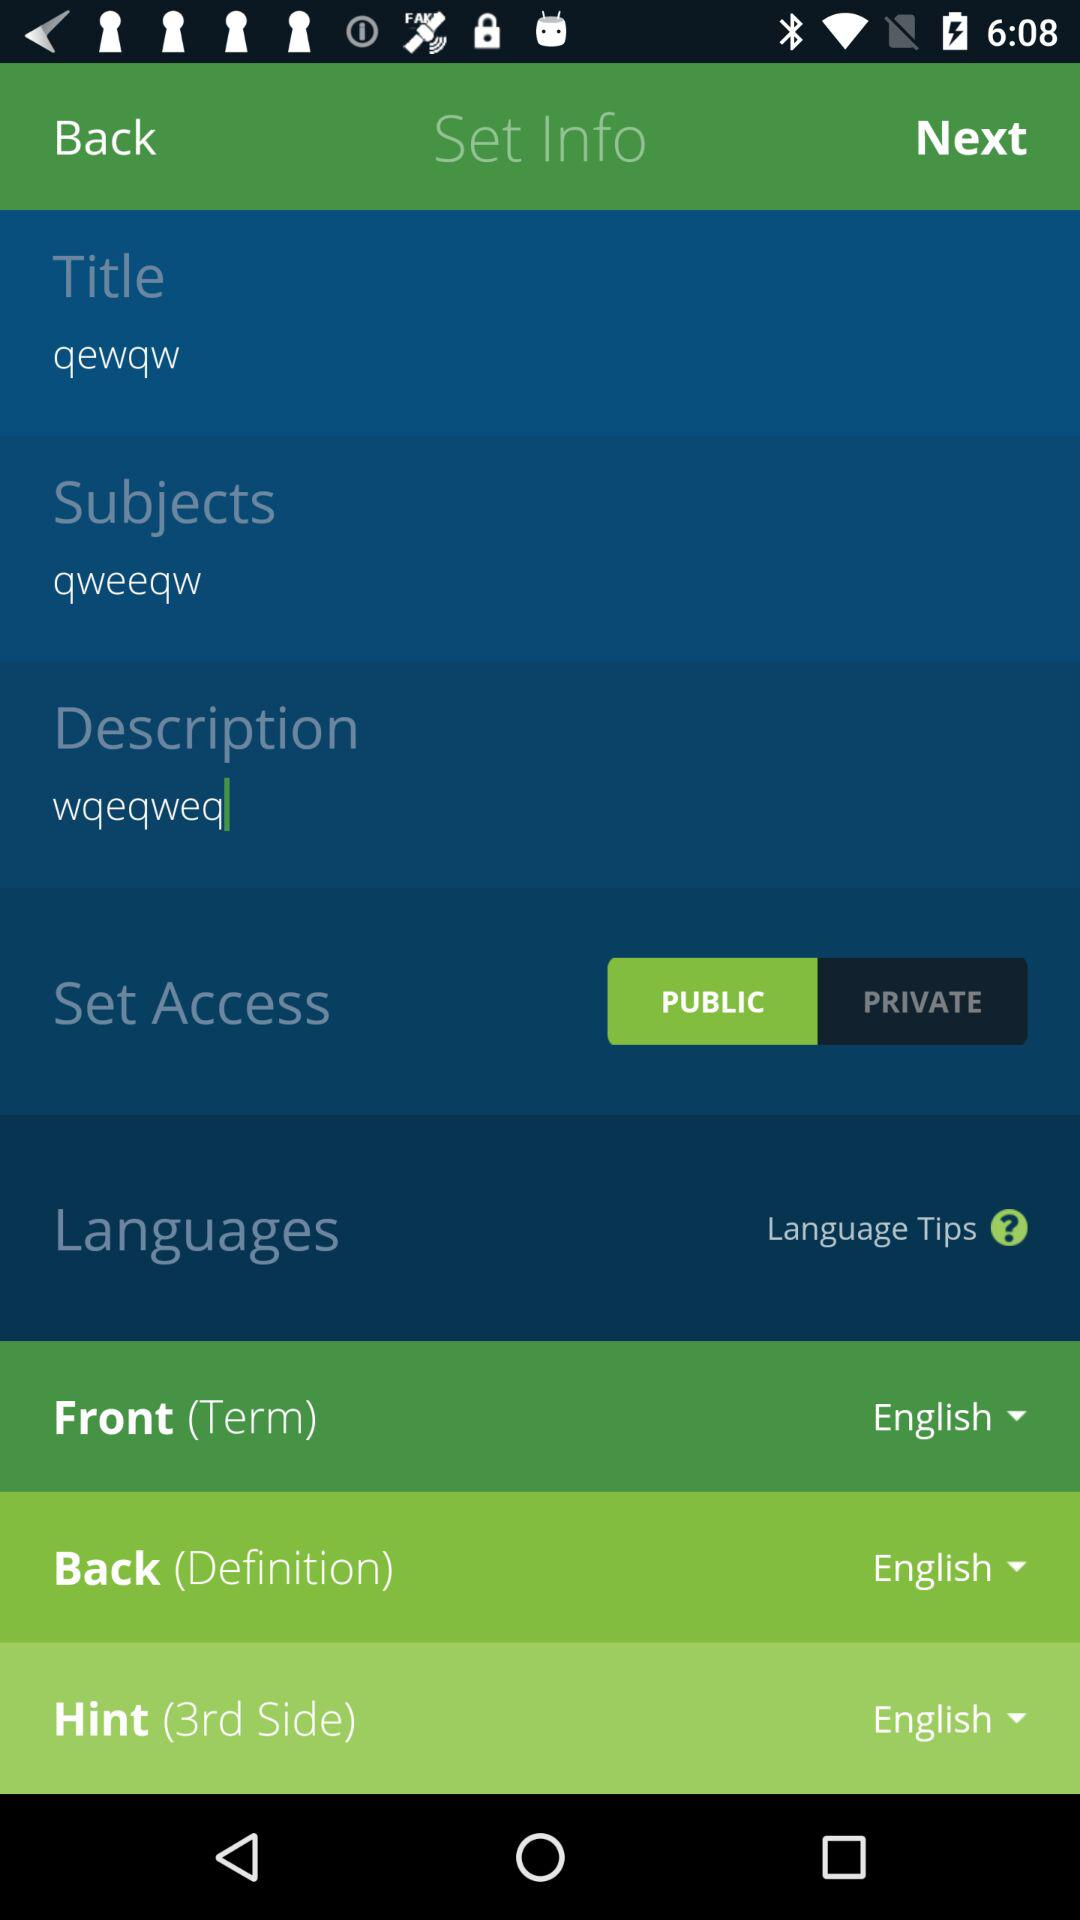What is the shown title? The shown title is "qewqw". 